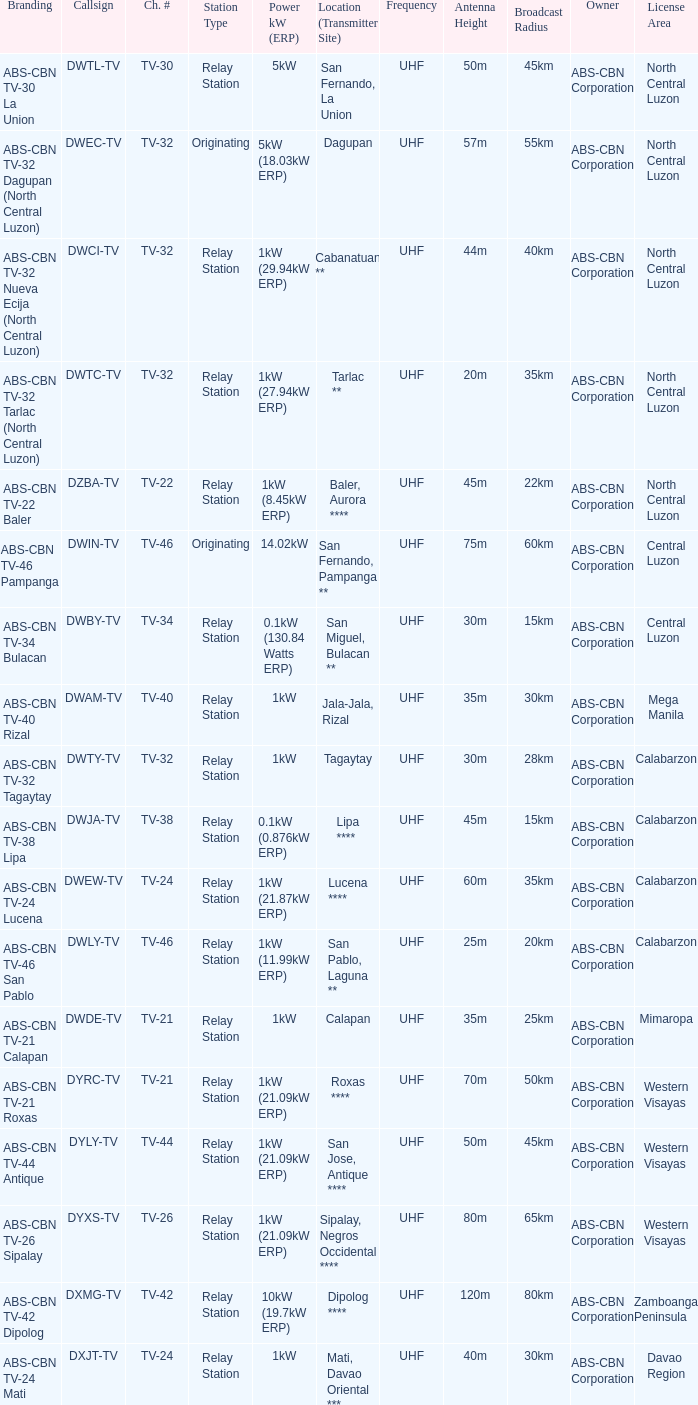The location (transmitter site) San Fernando, Pampanga ** has what Power kW (ERP)? 14.02kW. 